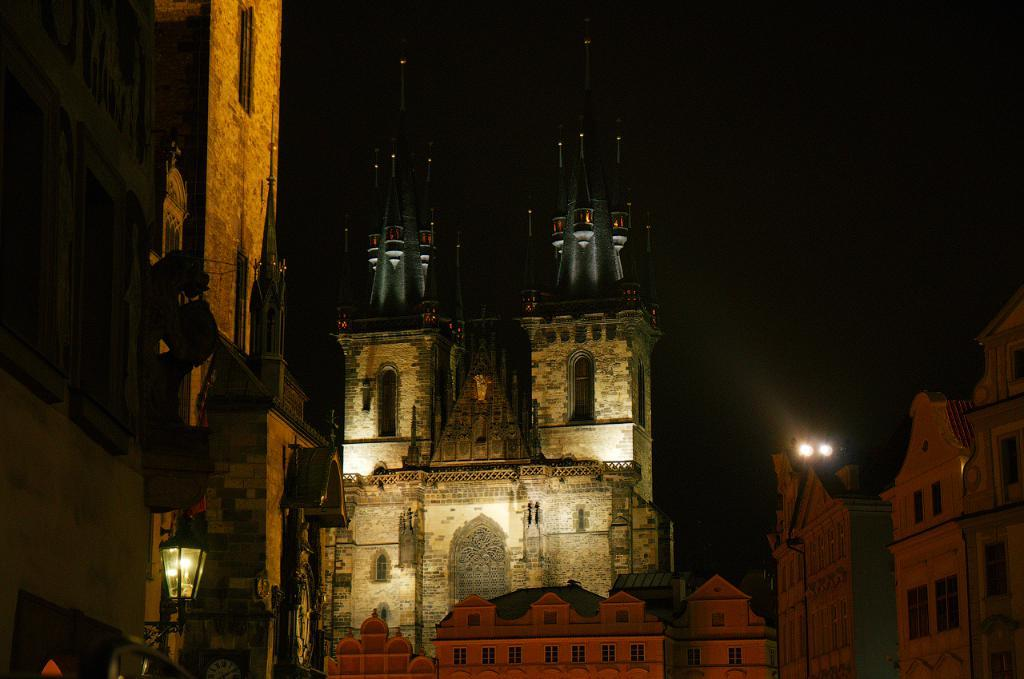What type of structures can be seen in the picture? There are buildings in the picture. Are there any other elements visible in the picture besides the buildings? Yes, lights are visible in the picture. How would you describe the sky in the image? The sky appears to be dark in the image. How many bikes are parked near the buildings in the image? There is no information about bikes in the image, so we cannot determine if any are present. 